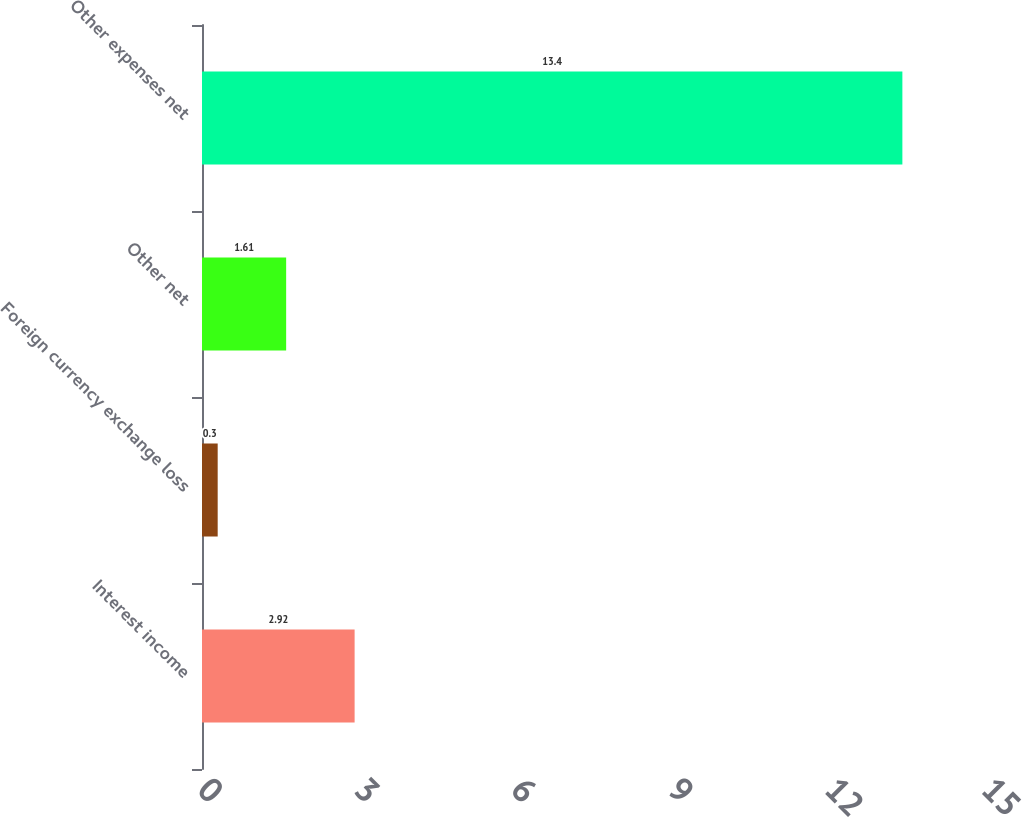<chart> <loc_0><loc_0><loc_500><loc_500><bar_chart><fcel>Interest income<fcel>Foreign currency exchange loss<fcel>Other net<fcel>Other expenses net<nl><fcel>2.92<fcel>0.3<fcel>1.61<fcel>13.4<nl></chart> 